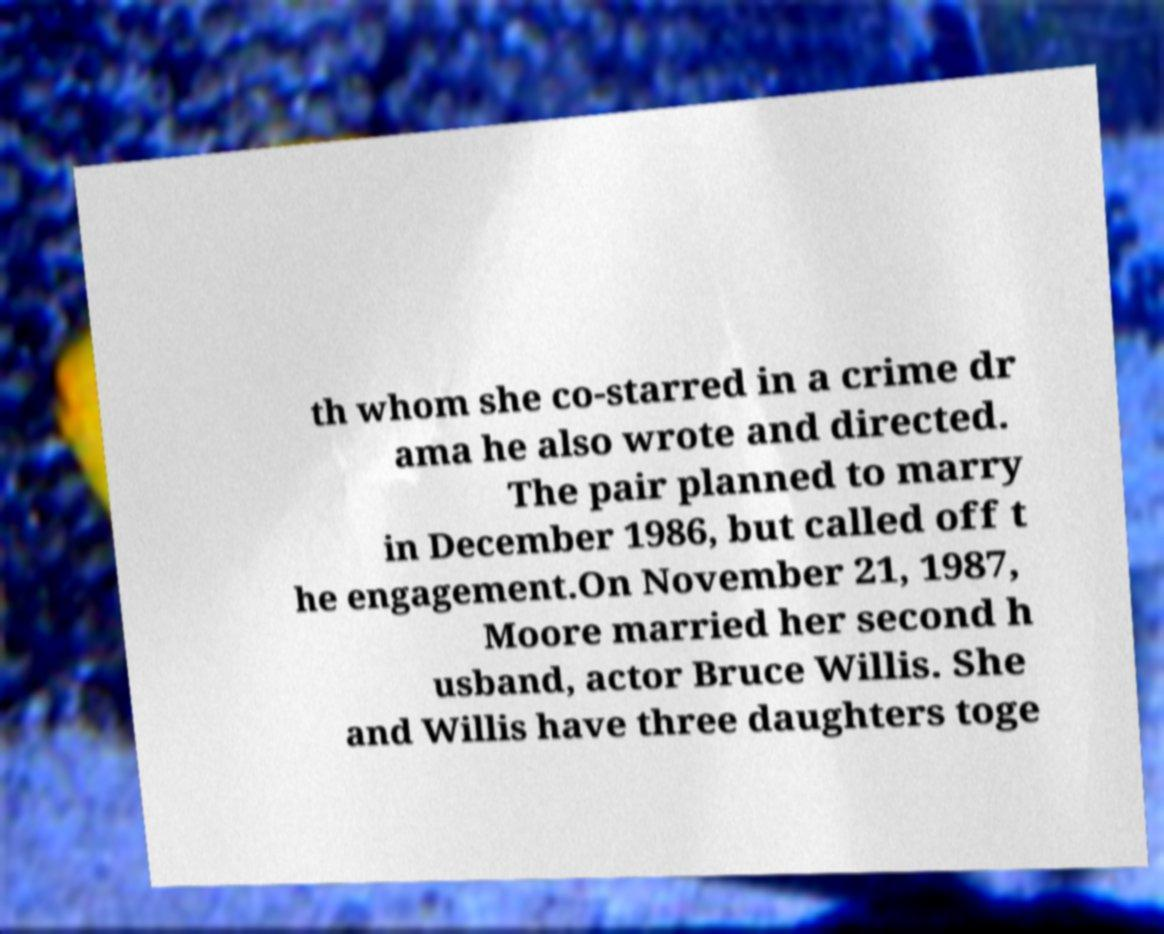There's text embedded in this image that I need extracted. Can you transcribe it verbatim? th whom she co-starred in a crime dr ama he also wrote and directed. The pair planned to marry in December 1986, but called off t he engagement.On November 21, 1987, Moore married her second h usband, actor Bruce Willis. She and Willis have three daughters toge 